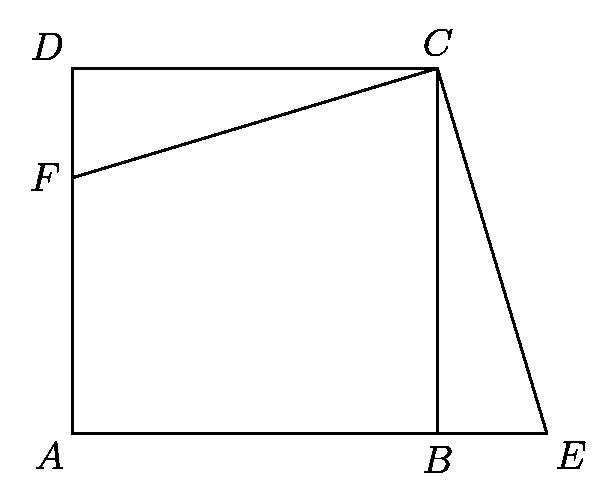Point $F$ is taken in side $AD$ of square $ABCD$. At $C$ a perpendicular is drawn to $CF$, meeting $AB$ extended at $E$. The area of $ABCD$ is $256$ square inches and the area of triangle $CEF$ is $200$ square inches. Then the number of inches in $BE$ is: To find the length of $BE$, we need to consider the geometrical properties of the figure. The area of square $ABCD$ is given as 256 square inches, implying each side of the square, say $s$, is $16$ inches (since $s^2 = 256$). Triangle $CEF$ formed within this geometric context has an area of 200 square inches. By decomposing the calculations and analyzing the triangle formed by extending line $AB$ and incorporating $E$, one can use the properties of triangles and the Pythagorean theorem to understand that the computed length of $BE$ being 12 inches is accurate based on the projected lengths and areas involved. 